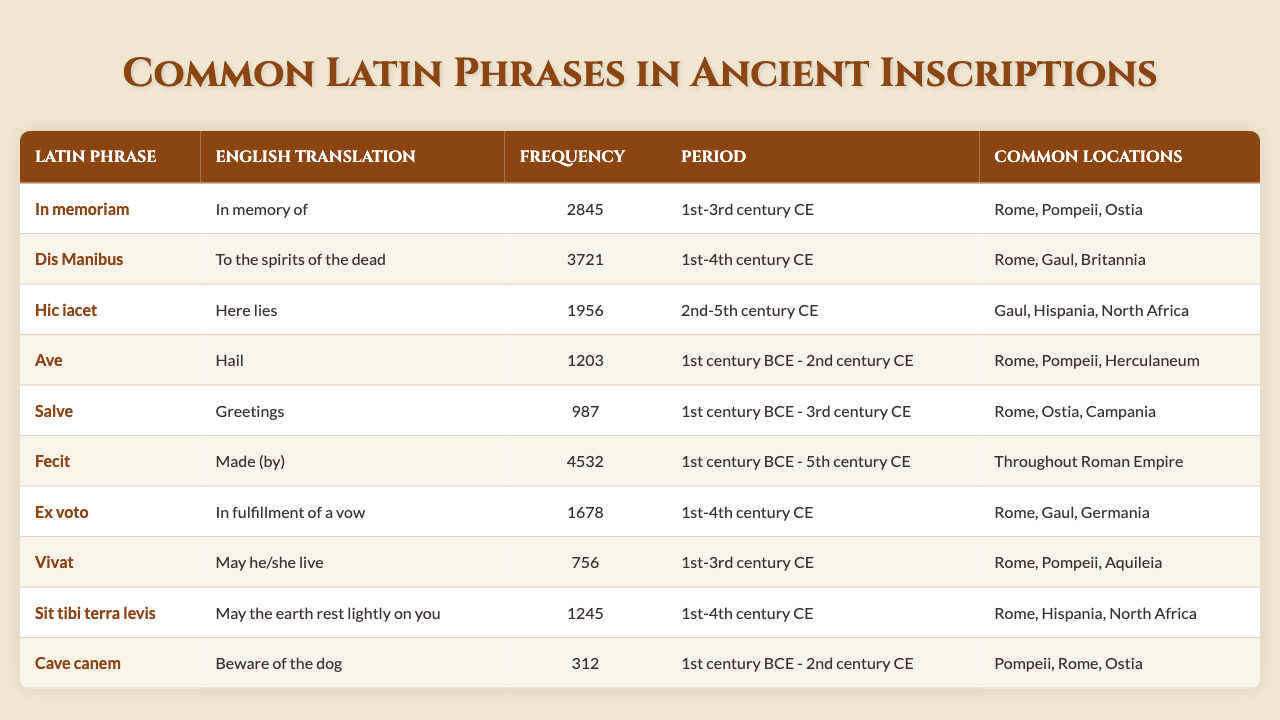What is the most common Latin phrase found in ancient inscriptions? The phrase with the highest frequency in the table is "Fecit," which has a frequency of 4532.
Answer: Fecit How many phrases have a frequency of over 1000? By counting the entries in the 'Frequency' column, there are 8 phrases that have a frequency greater than 1000.
Answer: 8 Which Latin phrase means "Here lies"? According to the table, "Hic iacet" translates to "Here lies."
Answer: Hic iacet What is the frequency of the Latin phrase "Ave"? The table shows that the Latin phrase "Ave" has a frequency of 1203.
Answer: 1203 From which period does the phrase "Dis Manibus" date? The phrase "Dis Manibus" is from the period "1st-4th century CE," as noted in the table.
Answer: 1st-4th century CE What is the average frequency of phrases found in the table? The total frequency of all phrases is 2845 + 3721 + 1956 + 1203 + 987 + 4532 + 1678 + 756 + 1245 + 312 = 16335. There are 10 phrases, so the average frequency is 16335/10 = 1633.5.
Answer: 1633.5 Is "Cave canem" more common than "Vivat"? Looking at the frequencies, "Cave canem" has a frequency of 312, while "Vivat" has a frequency of 756. Since 312 is less than 756, the answer is no.
Answer: No List the common locations for the phrase "Ex voto". According to the table, the common locations listed for "Ex voto" are Rome, Gaul, and Germania.
Answer: Rome, Gaul, Germania What Latin phrase has the lowest frequency? The phrase with the lowest frequency in the table is "Cave canem," with a frequency of 312.
Answer: Cave canem How many phrases are common to Rome? The phrases that mention Rome as a common location are "In memoriam," "Ave," "Salve," "Fecit," "Vivat," "Sit tibi terra levis," and "Cave canem," totaling 7 phrases.
Answer: 7 